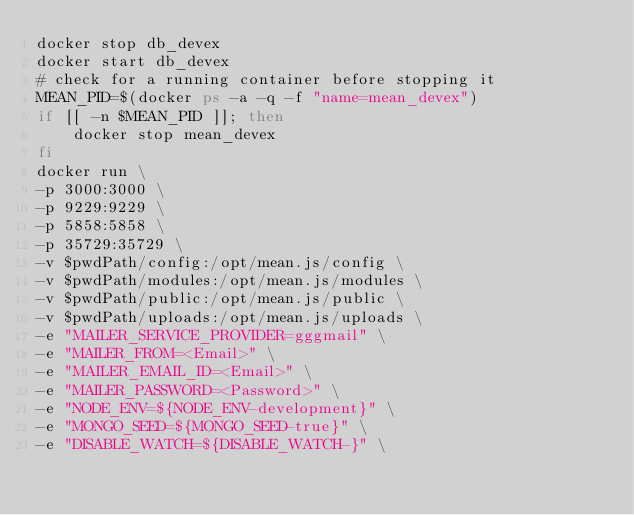<code> <loc_0><loc_0><loc_500><loc_500><_Bash_>docker stop db_devex
docker start db_devex
# check for a running container before stopping it
MEAN_PID=$(docker ps -a -q -f "name=mean_devex")
if [[ -n $MEAN_PID ]]; then
    docker stop mean_devex
fi
docker run \
-p 3000:3000 \
-p 9229:9229 \
-p 5858:5858 \
-p 35729:35729 \
-v $pwdPath/config:/opt/mean.js/config \
-v $pwdPath/modules:/opt/mean.js/modules \
-v $pwdPath/public:/opt/mean.js/public \
-v $pwdPath/uploads:/opt/mean.js/uploads \
-e "MAILER_SERVICE_PROVIDER=gggmail" \
-e "MAILER_FROM=<Email>" \
-e "MAILER_EMAIL_ID=<Email>" \
-e "MAILER_PASSWORD=<Password>" \
-e "NODE_ENV=${NODE_ENV-development}" \
-e "MONGO_SEED=${MONGO_SEED-true}" \
-e "DISABLE_WATCH=${DISABLE_WATCH-}" \</code> 